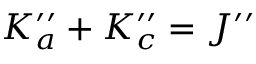Convert formula to latex. <formula><loc_0><loc_0><loc_500><loc_500>K _ { a } ^ { \prime \prime } + K _ { c } ^ { \prime \prime } = J ^ { \prime \prime }</formula> 